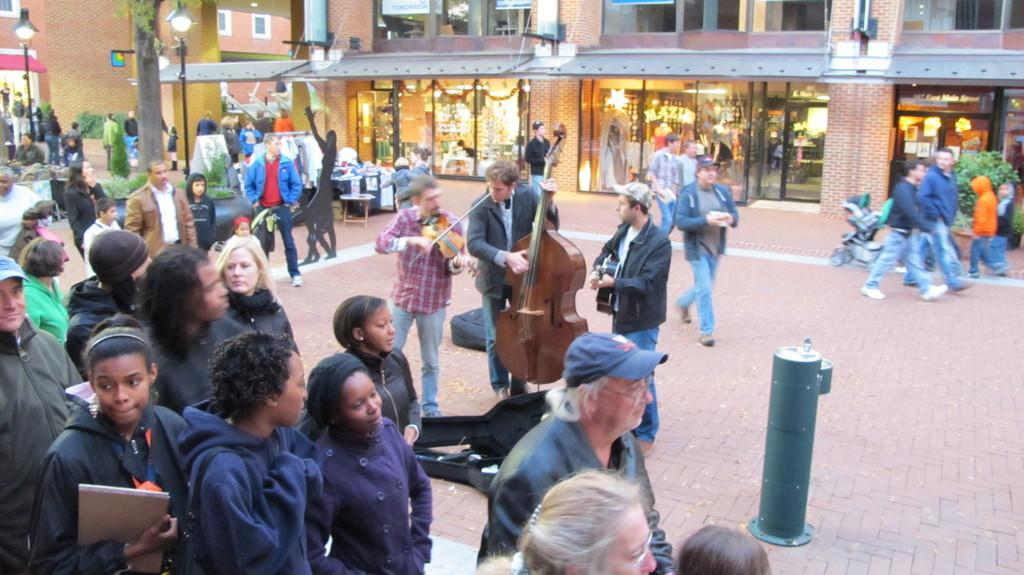What are the people in the image doing? The people in the image are standing and walking. Are any of the people holding anything specific? Yes, some people are holding musical instruments. What can be seen in the background of the image? In the background, there are plants, clothes, tables, poles, trees, and buildings. Can you see any waves in the image? No, there are no waves present in the image. Is there a plane visible in the image? No, there is no plane visible in the image. 